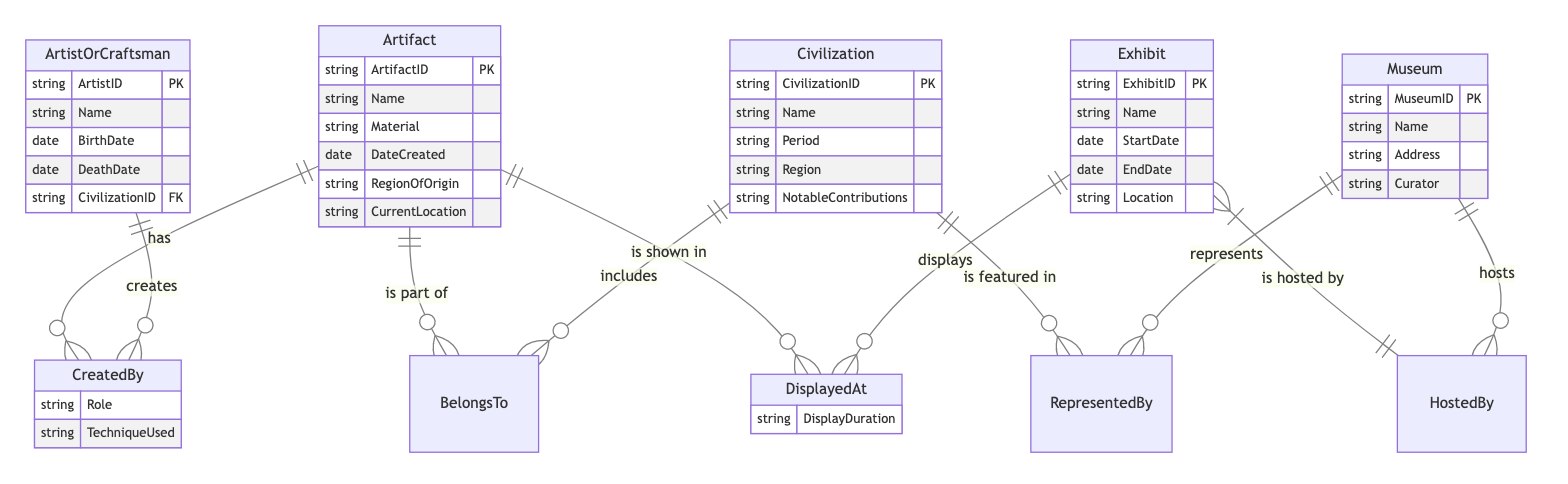What is the primary key of the Artifact entity? The diagram specifies that the primary key for the Artifact entity is "ArtifactID" which uniquely identifies each artifact. This is indicated by the PK designation next to the attribute list for the Artifact entity.
Answer: ArtifactID How many entities are in the diagram? The diagram contains five distinct entities: Artifact, Civilization, ArtistOrCraftsman, Exhibit, and Museum. By counting these listed entities at the beginning of the diagram, we confirm the total.
Answer: 5 What relationship connects Artifact and ArtistOrCraftsman? The diagram shows that the relationship between Artifact and ArtistOrCraftsman is named "CreatedBy." This relationship indicates that artifacts are created by artists or craftsmen. This is visually connected by lines in the diagram.
Answer: CreatedBy What is the role of the Exhibit entity in the diagram? The Exhibit entity serves multiple roles including being displayed at an exhibit and being hosted by a museum. Its relationships with Artifact (DisplayedAt) and Museum (HostedBy) signify its central role in showcasing artifacts.
Answer: DisplayedAt, HostedBy How many attributes does the Civilization entity have? The Civilization entity has five attributes: CivilizationID, Name, Period, Region, and NotableContributions. Counting these attributes in the entity structure provides the answer.
Answer: 5 Which entity has a date range (StartDate and EndDate)? The Exhibit entity includes two date attributes: StartDate and EndDate, indicating it has a date range related to the timeframe in which the exhibit is displayed. This can be seen directly in the attributes of the Exhibit entity.
Answer: Exhibit Which entity is a foreign key in the ArtistOrCraftsman entity? In the ArtistOrCraftsman entity, CivilizationID is designated as a foreign key (FK). This means it references the primary key of the Civilization entity, establishing a relationship between these two entities.
Answer: CivilizationID What type of relationship exists between Civilization and Museum? The relationship between Civilization and Museum is referred to as "RepresentedBy." This indicates that each civilization can be featured or represented by multiple museums, as represented by the connecting line in the diagram.
Answer: RepresentedBy What attribute describes the duration of the display for an artifact? The attribute that describes the duration for which an artifact is displayed in an exhibit is called "DisplayDuration." This is stated under the relationship "DisplayedAt" where it connects Artifact and Exhibit.
Answer: DisplayDuration 